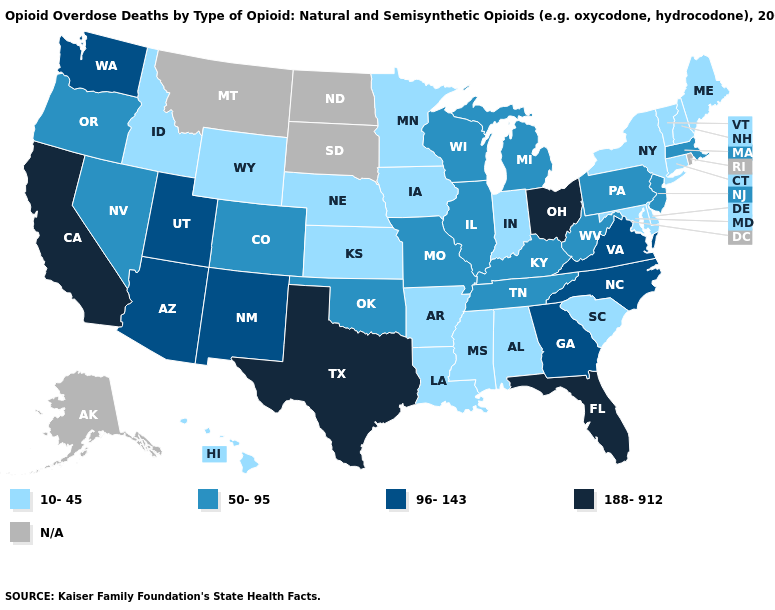Is the legend a continuous bar?
Write a very short answer. No. Name the states that have a value in the range 50-95?
Be succinct. Colorado, Illinois, Kentucky, Massachusetts, Michigan, Missouri, Nevada, New Jersey, Oklahoma, Oregon, Pennsylvania, Tennessee, West Virginia, Wisconsin. Name the states that have a value in the range N/A?
Quick response, please. Alaska, Montana, North Dakota, Rhode Island, South Dakota. What is the value of Wyoming?
Be succinct. 10-45. Name the states that have a value in the range 188-912?
Write a very short answer. California, Florida, Ohio, Texas. What is the highest value in states that border Texas?
Write a very short answer. 96-143. Among the states that border Georgia , does Alabama have the lowest value?
Write a very short answer. Yes. Does North Carolina have the lowest value in the South?
Write a very short answer. No. Among the states that border South Dakota , which have the highest value?
Concise answer only. Iowa, Minnesota, Nebraska, Wyoming. What is the value of West Virginia?
Write a very short answer. 50-95. How many symbols are there in the legend?
Concise answer only. 5. Among the states that border Delaware , which have the highest value?
Write a very short answer. New Jersey, Pennsylvania. Among the states that border Wisconsin , does Minnesota have the lowest value?
Quick response, please. Yes. What is the highest value in states that border Wisconsin?
Concise answer only. 50-95. 